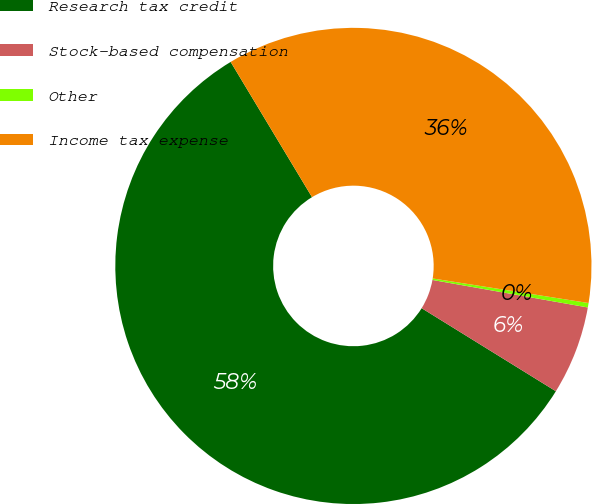<chart> <loc_0><loc_0><loc_500><loc_500><pie_chart><fcel>Research tax credit<fcel>Stock-based compensation<fcel>Other<fcel>Income tax expense<nl><fcel>57.56%<fcel>6.03%<fcel>0.3%<fcel>36.11%<nl></chart> 